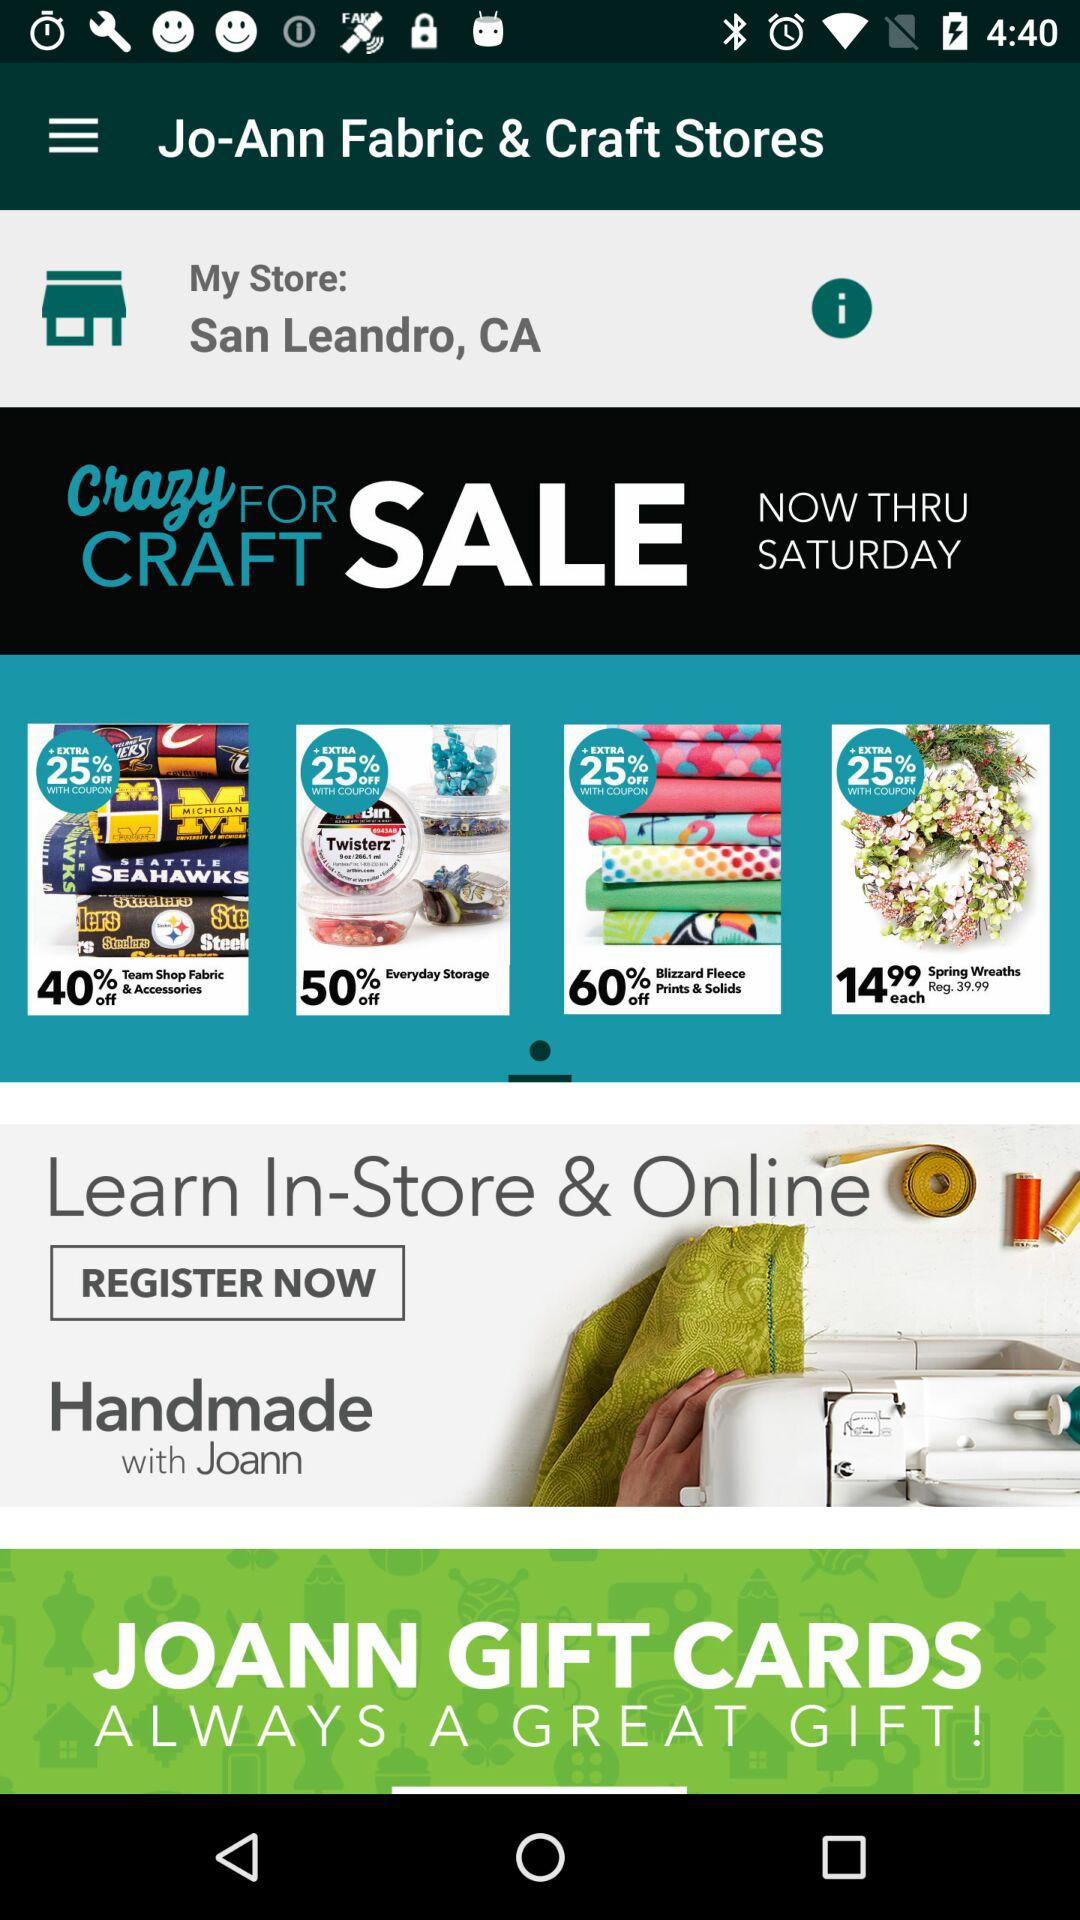How many items are on sale?
Answer the question using a single word or phrase. 4 